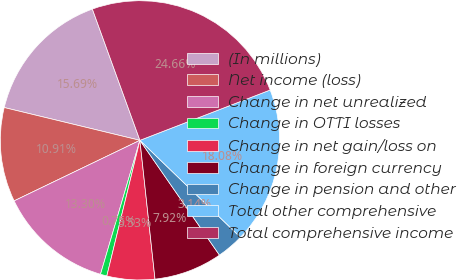<chart> <loc_0><loc_0><loc_500><loc_500><pie_chart><fcel>(In millions)<fcel>Net income (loss)<fcel>Change in net unrealized<fcel>Change in OTTI losses<fcel>Change in net gain/loss on<fcel>Change in foreign currency<fcel>Change in pension and other<fcel>Total other comprehensive<fcel>Total comprehensive income<nl><fcel>15.69%<fcel>10.91%<fcel>13.3%<fcel>0.75%<fcel>5.53%<fcel>7.92%<fcel>3.14%<fcel>18.08%<fcel>24.66%<nl></chart> 